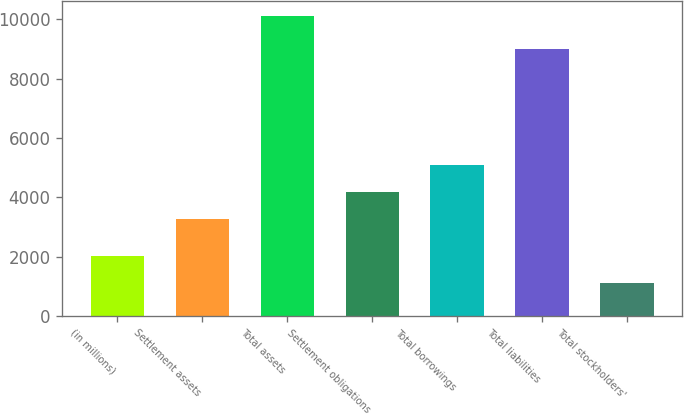Convert chart to OTSL. <chart><loc_0><loc_0><loc_500><loc_500><bar_chart><fcel>(in millions)<fcel>Settlement assets<fcel>Total assets<fcel>Settlement obligations<fcel>Total borrowings<fcel>Total liabilities<fcel>Total stockholders'<nl><fcel>2013<fcel>3270.4<fcel>10105.4<fcel>4170.47<fcel>5070.54<fcel>9000.7<fcel>1104.7<nl></chart> 